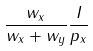Convert formula to latex. <formula><loc_0><loc_0><loc_500><loc_500>\frac { w _ { x } } { w _ { x } + w _ { y } } \frac { I } { p _ { x } }</formula> 